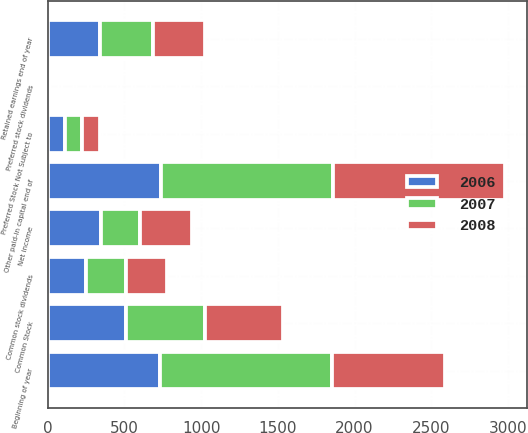<chart> <loc_0><loc_0><loc_500><loc_500><stacked_bar_chart><ecel><fcel>Common Stock<fcel>Beginning of year<fcel>Other paid-in capital end of<fcel>Preferred Stock Not Subject to<fcel>Net income<fcel>Common stock dividends<fcel>Preferred stock dividends<fcel>Retained earnings end of year<nl><fcel>2007<fcel>511<fcel>1119<fcel>1119<fcel>113<fcel>251<fcel>264<fcel>6<fcel>342<nl><fcel>2008<fcel>511<fcel>739<fcel>1119<fcel>113<fcel>342<fcel>267<fcel>6<fcel>342<nl><fcel>2006<fcel>511<fcel>733<fcel>739<fcel>113<fcel>349<fcel>249<fcel>6<fcel>342<nl></chart> 